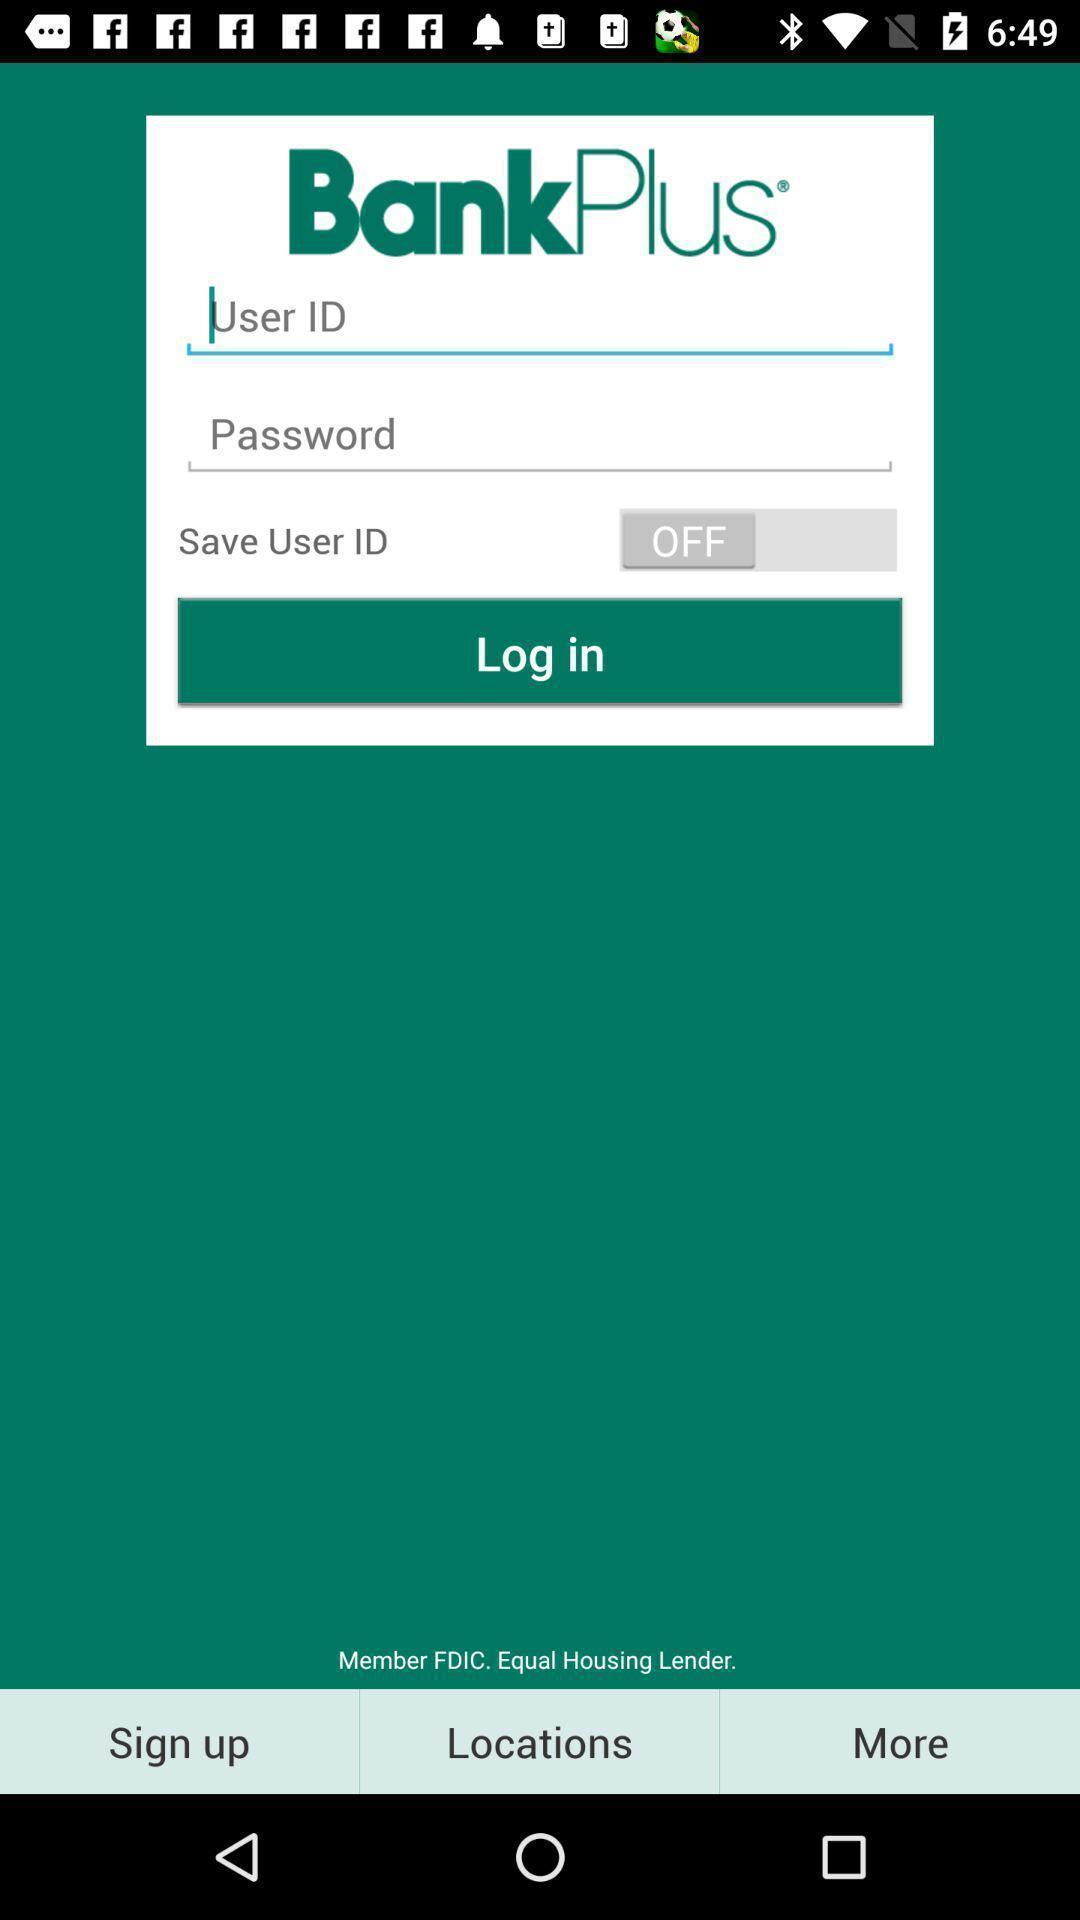Describe the content in this image. Page displaying signing in information about a banking application. 